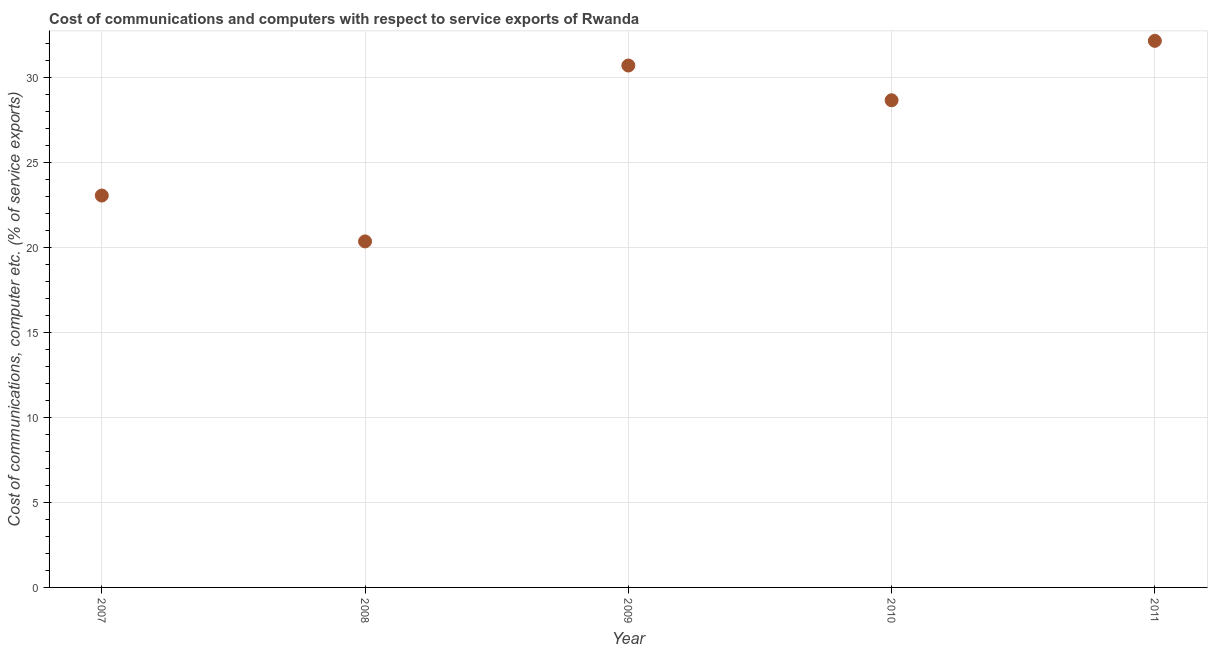What is the cost of communications and computer in 2009?
Give a very brief answer. 30.71. Across all years, what is the maximum cost of communications and computer?
Give a very brief answer. 32.16. Across all years, what is the minimum cost of communications and computer?
Offer a terse response. 20.36. What is the sum of the cost of communications and computer?
Your answer should be very brief. 134.95. What is the difference between the cost of communications and computer in 2008 and 2011?
Give a very brief answer. -11.8. What is the average cost of communications and computer per year?
Your response must be concise. 26.99. What is the median cost of communications and computer?
Your answer should be compact. 28.66. What is the ratio of the cost of communications and computer in 2007 to that in 2009?
Offer a terse response. 0.75. Is the difference between the cost of communications and computer in 2008 and 2011 greater than the difference between any two years?
Your response must be concise. Yes. What is the difference between the highest and the second highest cost of communications and computer?
Give a very brief answer. 1.45. What is the difference between the highest and the lowest cost of communications and computer?
Your answer should be compact. 11.8. Does the cost of communications and computer monotonically increase over the years?
Your response must be concise. No. How many dotlines are there?
Give a very brief answer. 1. What is the difference between two consecutive major ticks on the Y-axis?
Ensure brevity in your answer.  5. Are the values on the major ticks of Y-axis written in scientific E-notation?
Make the answer very short. No. Does the graph contain grids?
Provide a succinct answer. Yes. What is the title of the graph?
Give a very brief answer. Cost of communications and computers with respect to service exports of Rwanda. What is the label or title of the Y-axis?
Your answer should be compact. Cost of communications, computer etc. (% of service exports). What is the Cost of communications, computer etc. (% of service exports) in 2007?
Offer a terse response. 23.06. What is the Cost of communications, computer etc. (% of service exports) in 2008?
Keep it short and to the point. 20.36. What is the Cost of communications, computer etc. (% of service exports) in 2009?
Give a very brief answer. 30.71. What is the Cost of communications, computer etc. (% of service exports) in 2010?
Make the answer very short. 28.66. What is the Cost of communications, computer etc. (% of service exports) in 2011?
Keep it short and to the point. 32.16. What is the difference between the Cost of communications, computer etc. (% of service exports) in 2007 and 2008?
Ensure brevity in your answer.  2.7. What is the difference between the Cost of communications, computer etc. (% of service exports) in 2007 and 2009?
Ensure brevity in your answer.  -7.65. What is the difference between the Cost of communications, computer etc. (% of service exports) in 2007 and 2010?
Your response must be concise. -5.61. What is the difference between the Cost of communications, computer etc. (% of service exports) in 2007 and 2011?
Provide a short and direct response. -9.1. What is the difference between the Cost of communications, computer etc. (% of service exports) in 2008 and 2009?
Your response must be concise. -10.35. What is the difference between the Cost of communications, computer etc. (% of service exports) in 2008 and 2010?
Ensure brevity in your answer.  -8.3. What is the difference between the Cost of communications, computer etc. (% of service exports) in 2008 and 2011?
Ensure brevity in your answer.  -11.8. What is the difference between the Cost of communications, computer etc. (% of service exports) in 2009 and 2010?
Your answer should be very brief. 2.04. What is the difference between the Cost of communications, computer etc. (% of service exports) in 2009 and 2011?
Keep it short and to the point. -1.45. What is the difference between the Cost of communications, computer etc. (% of service exports) in 2010 and 2011?
Offer a very short reply. -3.5. What is the ratio of the Cost of communications, computer etc. (% of service exports) in 2007 to that in 2008?
Your answer should be compact. 1.13. What is the ratio of the Cost of communications, computer etc. (% of service exports) in 2007 to that in 2009?
Your answer should be very brief. 0.75. What is the ratio of the Cost of communications, computer etc. (% of service exports) in 2007 to that in 2010?
Give a very brief answer. 0.8. What is the ratio of the Cost of communications, computer etc. (% of service exports) in 2007 to that in 2011?
Offer a very short reply. 0.72. What is the ratio of the Cost of communications, computer etc. (% of service exports) in 2008 to that in 2009?
Offer a terse response. 0.66. What is the ratio of the Cost of communications, computer etc. (% of service exports) in 2008 to that in 2010?
Ensure brevity in your answer.  0.71. What is the ratio of the Cost of communications, computer etc. (% of service exports) in 2008 to that in 2011?
Provide a short and direct response. 0.63. What is the ratio of the Cost of communications, computer etc. (% of service exports) in 2009 to that in 2010?
Your answer should be compact. 1.07. What is the ratio of the Cost of communications, computer etc. (% of service exports) in 2009 to that in 2011?
Provide a succinct answer. 0.95. What is the ratio of the Cost of communications, computer etc. (% of service exports) in 2010 to that in 2011?
Make the answer very short. 0.89. 